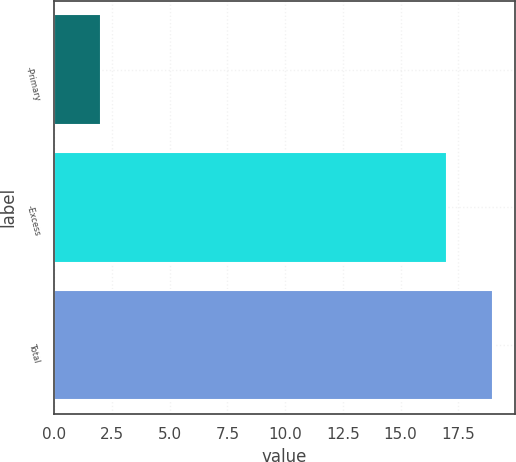Convert chart to OTSL. <chart><loc_0><loc_0><loc_500><loc_500><bar_chart><fcel>-Primary<fcel>-Excess<fcel>Total<nl><fcel>2<fcel>17<fcel>19<nl></chart> 